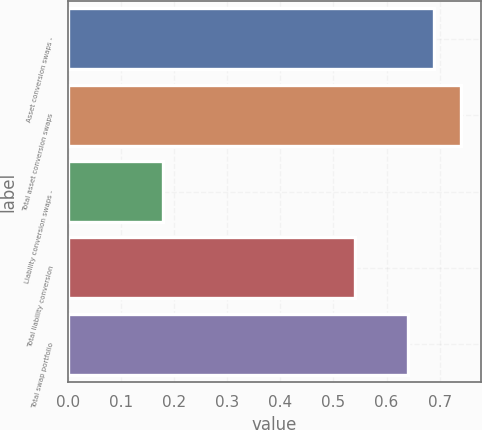Convert chart. <chart><loc_0><loc_0><loc_500><loc_500><bar_chart><fcel>Asset conversion swaps -<fcel>Total asset conversion swaps<fcel>Liability conversion swaps -<fcel>Total liability conversion<fcel>Total swap portfolio<nl><fcel>0.69<fcel>0.74<fcel>0.18<fcel>0.54<fcel>0.64<nl></chart> 